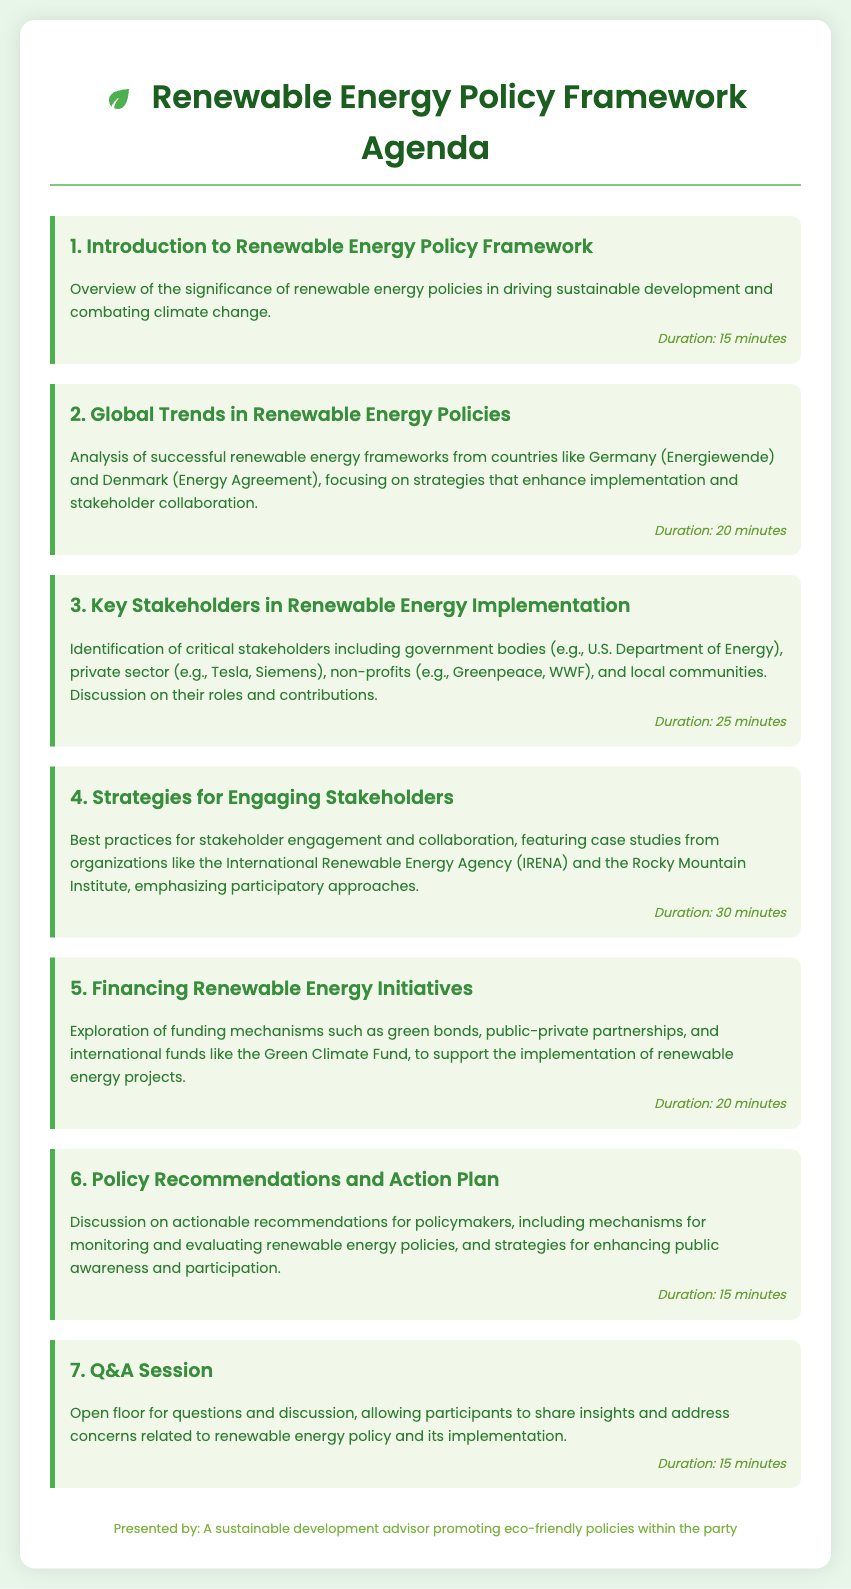What is the total duration for the agenda items? The total duration is the sum of all the individual durations specified for each agenda item.
Answer: 135 minutes Who is a key stakeholder mentioned in the document? The document identifies critical stakeholders including government bodies, private sector, non-profits, and local communities.
Answer: U.S. Department of Energy What is one funding mechanism for renewable energy initiatives? The document lists various funding mechanisms that support renewable energy projects.
Answer: Green bonds What is the duration for the "Strategies for Engaging Stakeholders" item? The document provides specific durations for each agenda item, allowing us to answer this question.
Answer: 30 minutes Which country is mentioned as having a successful renewable energy framework? The document refers to successful renewable energy frameworks from various countries, highlighting a few significant examples.
Answer: Germany What type of session concludes the agenda? The last agenda item specifically mentions the type of session included in the framework.
Answer: Q&A Session What organization is referenced in relation to best practices for stakeholder engagement? The document provides examples of notable organizations that are influential in the renewable energy sector and mentions their engagements.
Answer: International Renewable Energy Agency (IRENA) 